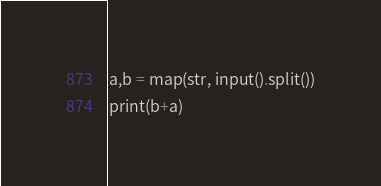<code> <loc_0><loc_0><loc_500><loc_500><_Python_>a,b = map(str, input().split())
print(b+a)</code> 